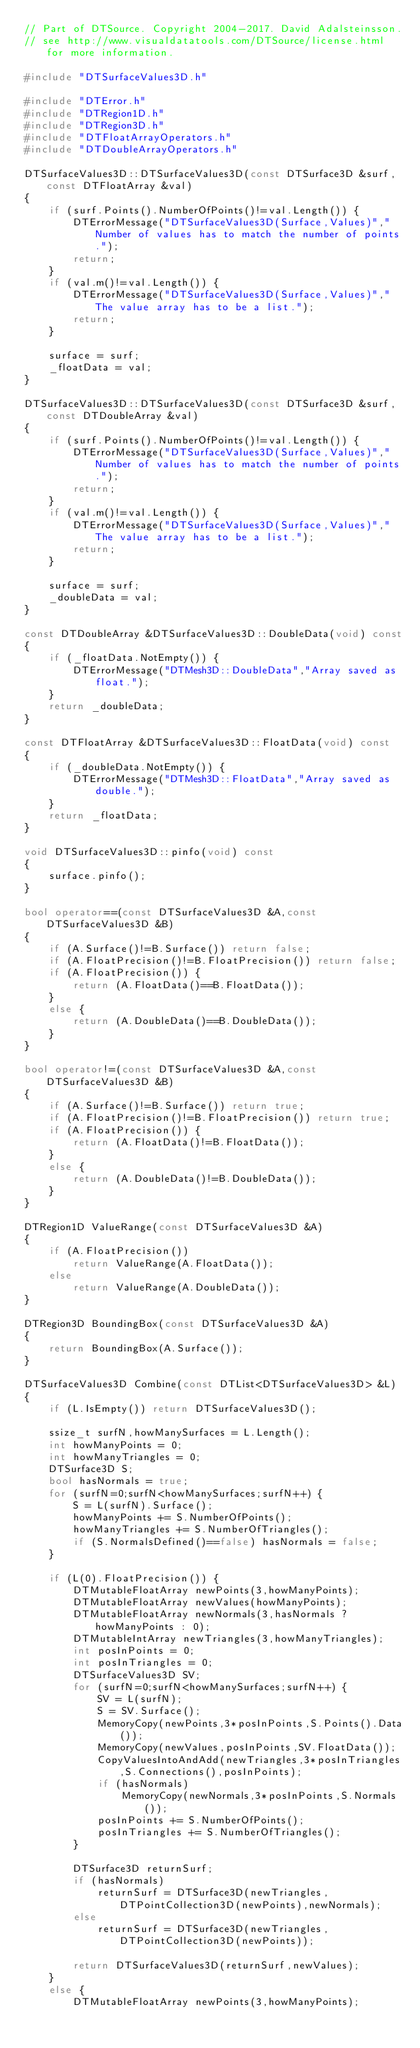<code> <loc_0><loc_0><loc_500><loc_500><_C++_>// Part of DTSource. Copyright 2004-2017. David Adalsteinsson.
// see http://www.visualdatatools.com/DTSource/license.html for more information.

#include "DTSurfaceValues3D.h"

#include "DTError.h"
#include "DTRegion1D.h"
#include "DTRegion3D.h"
#include "DTFloatArrayOperators.h"
#include "DTDoubleArrayOperators.h"

DTSurfaceValues3D::DTSurfaceValues3D(const DTSurface3D &surf,const DTFloatArray &val)
{
    if (surf.Points().NumberOfPoints()!=val.Length()) {
        DTErrorMessage("DTSurfaceValues3D(Surface,Values)","Number of values has to match the number of points.");
        return;
    }
    if (val.m()!=val.Length()) {
        DTErrorMessage("DTSurfaceValues3D(Surface,Values)","The value array has to be a list.");
        return;
    }

    surface = surf;
    _floatData = val;
}

DTSurfaceValues3D::DTSurfaceValues3D(const DTSurface3D &surf,const DTDoubleArray &val)
{
    if (surf.Points().NumberOfPoints()!=val.Length()) {
        DTErrorMessage("DTSurfaceValues3D(Surface,Values)","Number of values has to match the number of points.");
        return;
    }
    if (val.m()!=val.Length()) {
        DTErrorMessage("DTSurfaceValues3D(Surface,Values)","The value array has to be a list.");
        return;
    }
    
    surface = surf;
    _doubleData = val;
}

const DTDoubleArray &DTSurfaceValues3D::DoubleData(void) const
{
    if (_floatData.NotEmpty()) {
        DTErrorMessage("DTMesh3D::DoubleData","Array saved as float.");
    }
    return _doubleData;
}

const DTFloatArray &DTSurfaceValues3D::FloatData(void) const
{
    if (_doubleData.NotEmpty()) {
        DTErrorMessage("DTMesh3D::FloatData","Array saved as double.");
    }
    return _floatData;
}

void DTSurfaceValues3D::pinfo(void) const
{
    surface.pinfo();
}

bool operator==(const DTSurfaceValues3D &A,const DTSurfaceValues3D &B)
{
    if (A.Surface()!=B.Surface()) return false;
    if (A.FloatPrecision()!=B.FloatPrecision()) return false;
    if (A.FloatPrecision()) {
        return (A.FloatData()==B.FloatData());
    }
    else {
        return (A.DoubleData()==B.DoubleData());
    }
}

bool operator!=(const DTSurfaceValues3D &A,const DTSurfaceValues3D &B)
{
    if (A.Surface()!=B.Surface()) return true;
    if (A.FloatPrecision()!=B.FloatPrecision()) return true;
    if (A.FloatPrecision()) {
        return (A.FloatData()!=B.FloatData());
    }
    else {
        return (A.DoubleData()!=B.DoubleData());
    }
}

DTRegion1D ValueRange(const DTSurfaceValues3D &A)
{
    if (A.FloatPrecision())
        return ValueRange(A.FloatData());
    else
        return ValueRange(A.DoubleData());
}

DTRegion3D BoundingBox(const DTSurfaceValues3D &A)
{
    return BoundingBox(A.Surface());
}

DTSurfaceValues3D Combine(const DTList<DTSurfaceValues3D> &L)
{
    if (L.IsEmpty()) return DTSurfaceValues3D();
    
	ssize_t surfN,howManySurfaces = L.Length();
	int howManyPoints = 0;
	int howManyTriangles = 0;
	DTSurface3D S;
	bool hasNormals = true;
	for (surfN=0;surfN<howManySurfaces;surfN++) {
		S = L(surfN).Surface();
		howManyPoints += S.NumberOfPoints();
		howManyTriangles += S.NumberOfTriangles();
		if (S.NormalsDefined()==false) hasNormals = false;
	}
	
    if (L(0).FloatPrecision()) {
        DTMutableFloatArray newPoints(3,howManyPoints);
        DTMutableFloatArray newValues(howManyPoints);
        DTMutableFloatArray newNormals(3,hasNormals ? howManyPoints : 0);
        DTMutableIntArray newTriangles(3,howManyTriangles);
        int posInPoints = 0;
        int posInTriangles = 0;
        DTSurfaceValues3D SV;
        for (surfN=0;surfN<howManySurfaces;surfN++) {
            SV = L(surfN);
            S = SV.Surface();
            MemoryCopy(newPoints,3*posInPoints,S.Points().Data());
            MemoryCopy(newValues,posInPoints,SV.FloatData());
            CopyValuesIntoAndAdd(newTriangles,3*posInTriangles,S.Connections(),posInPoints);
            if (hasNormals)
                MemoryCopy(newNormals,3*posInPoints,S.Normals());
            posInPoints += S.NumberOfPoints();
            posInTriangles += S.NumberOfTriangles();
        }
        
        DTSurface3D returnSurf;
        if (hasNormals)
            returnSurf = DTSurface3D(newTriangles,DTPointCollection3D(newPoints),newNormals);
        else
            returnSurf = DTSurface3D(newTriangles,DTPointCollection3D(newPoints));
        
        return DTSurfaceValues3D(returnSurf,newValues);
    }
    else {
        DTMutableFloatArray newPoints(3,howManyPoints);</code> 